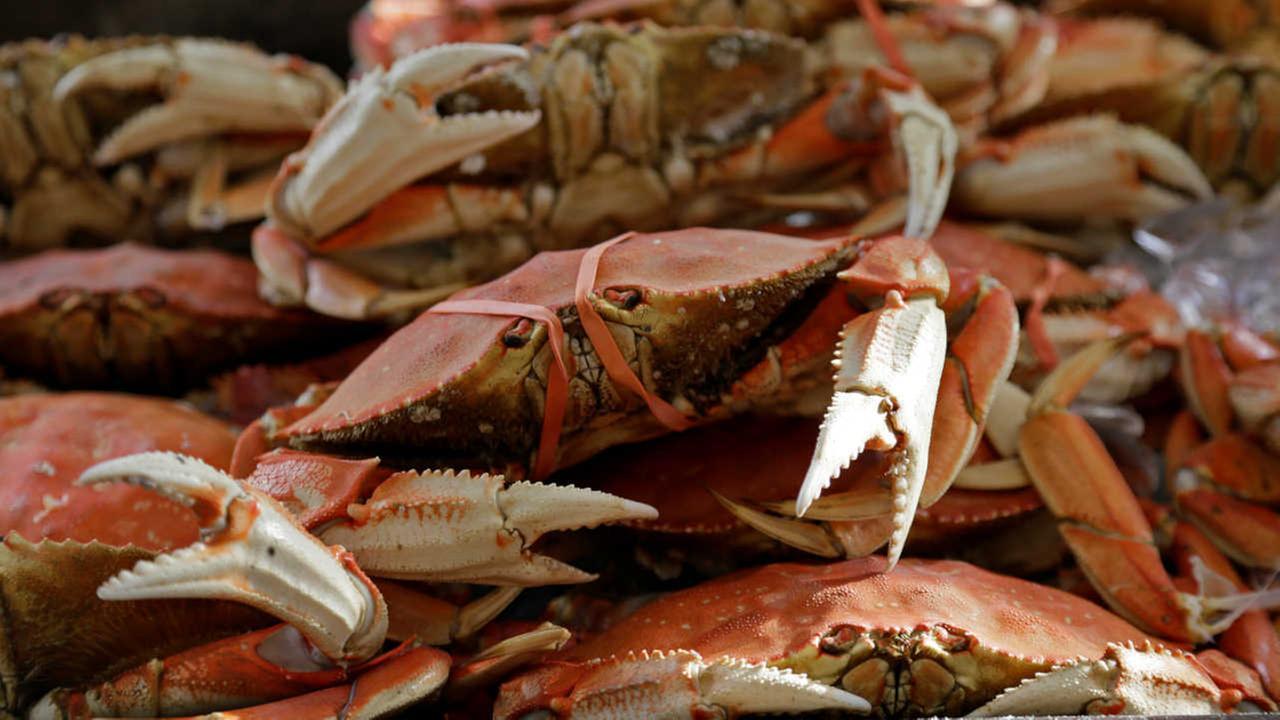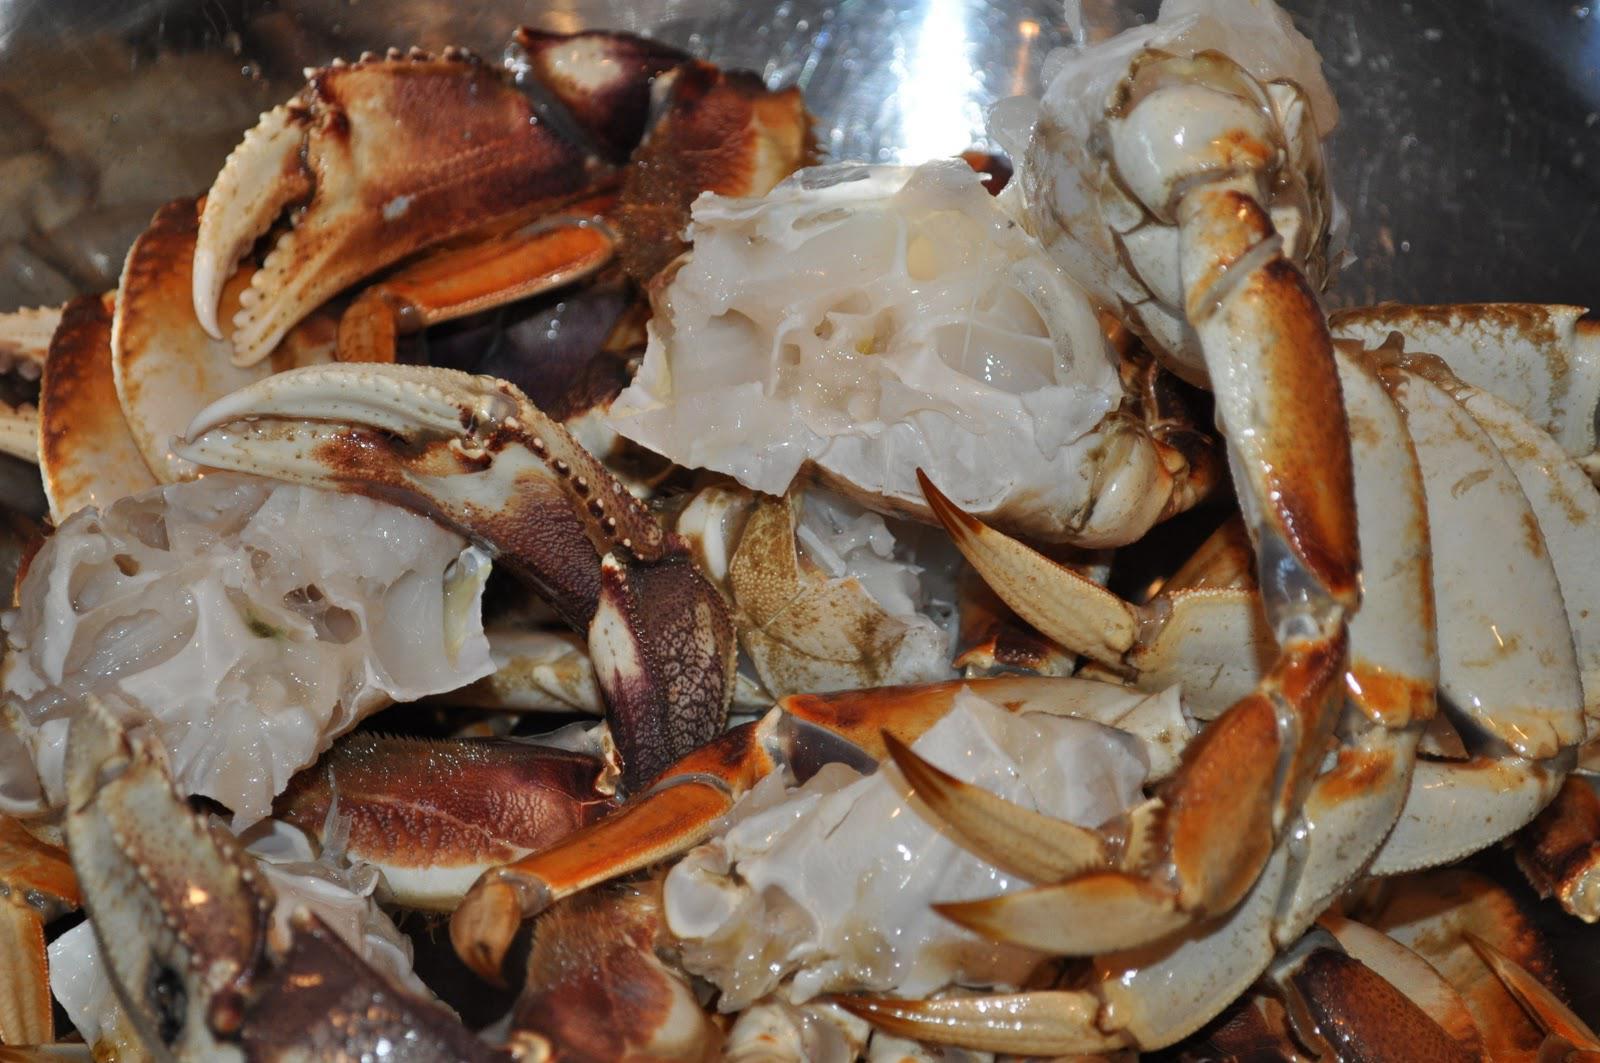The first image is the image on the left, the second image is the image on the right. Examine the images to the left and right. Is the description "There are exactly two crabs." accurate? Answer yes or no. No. 